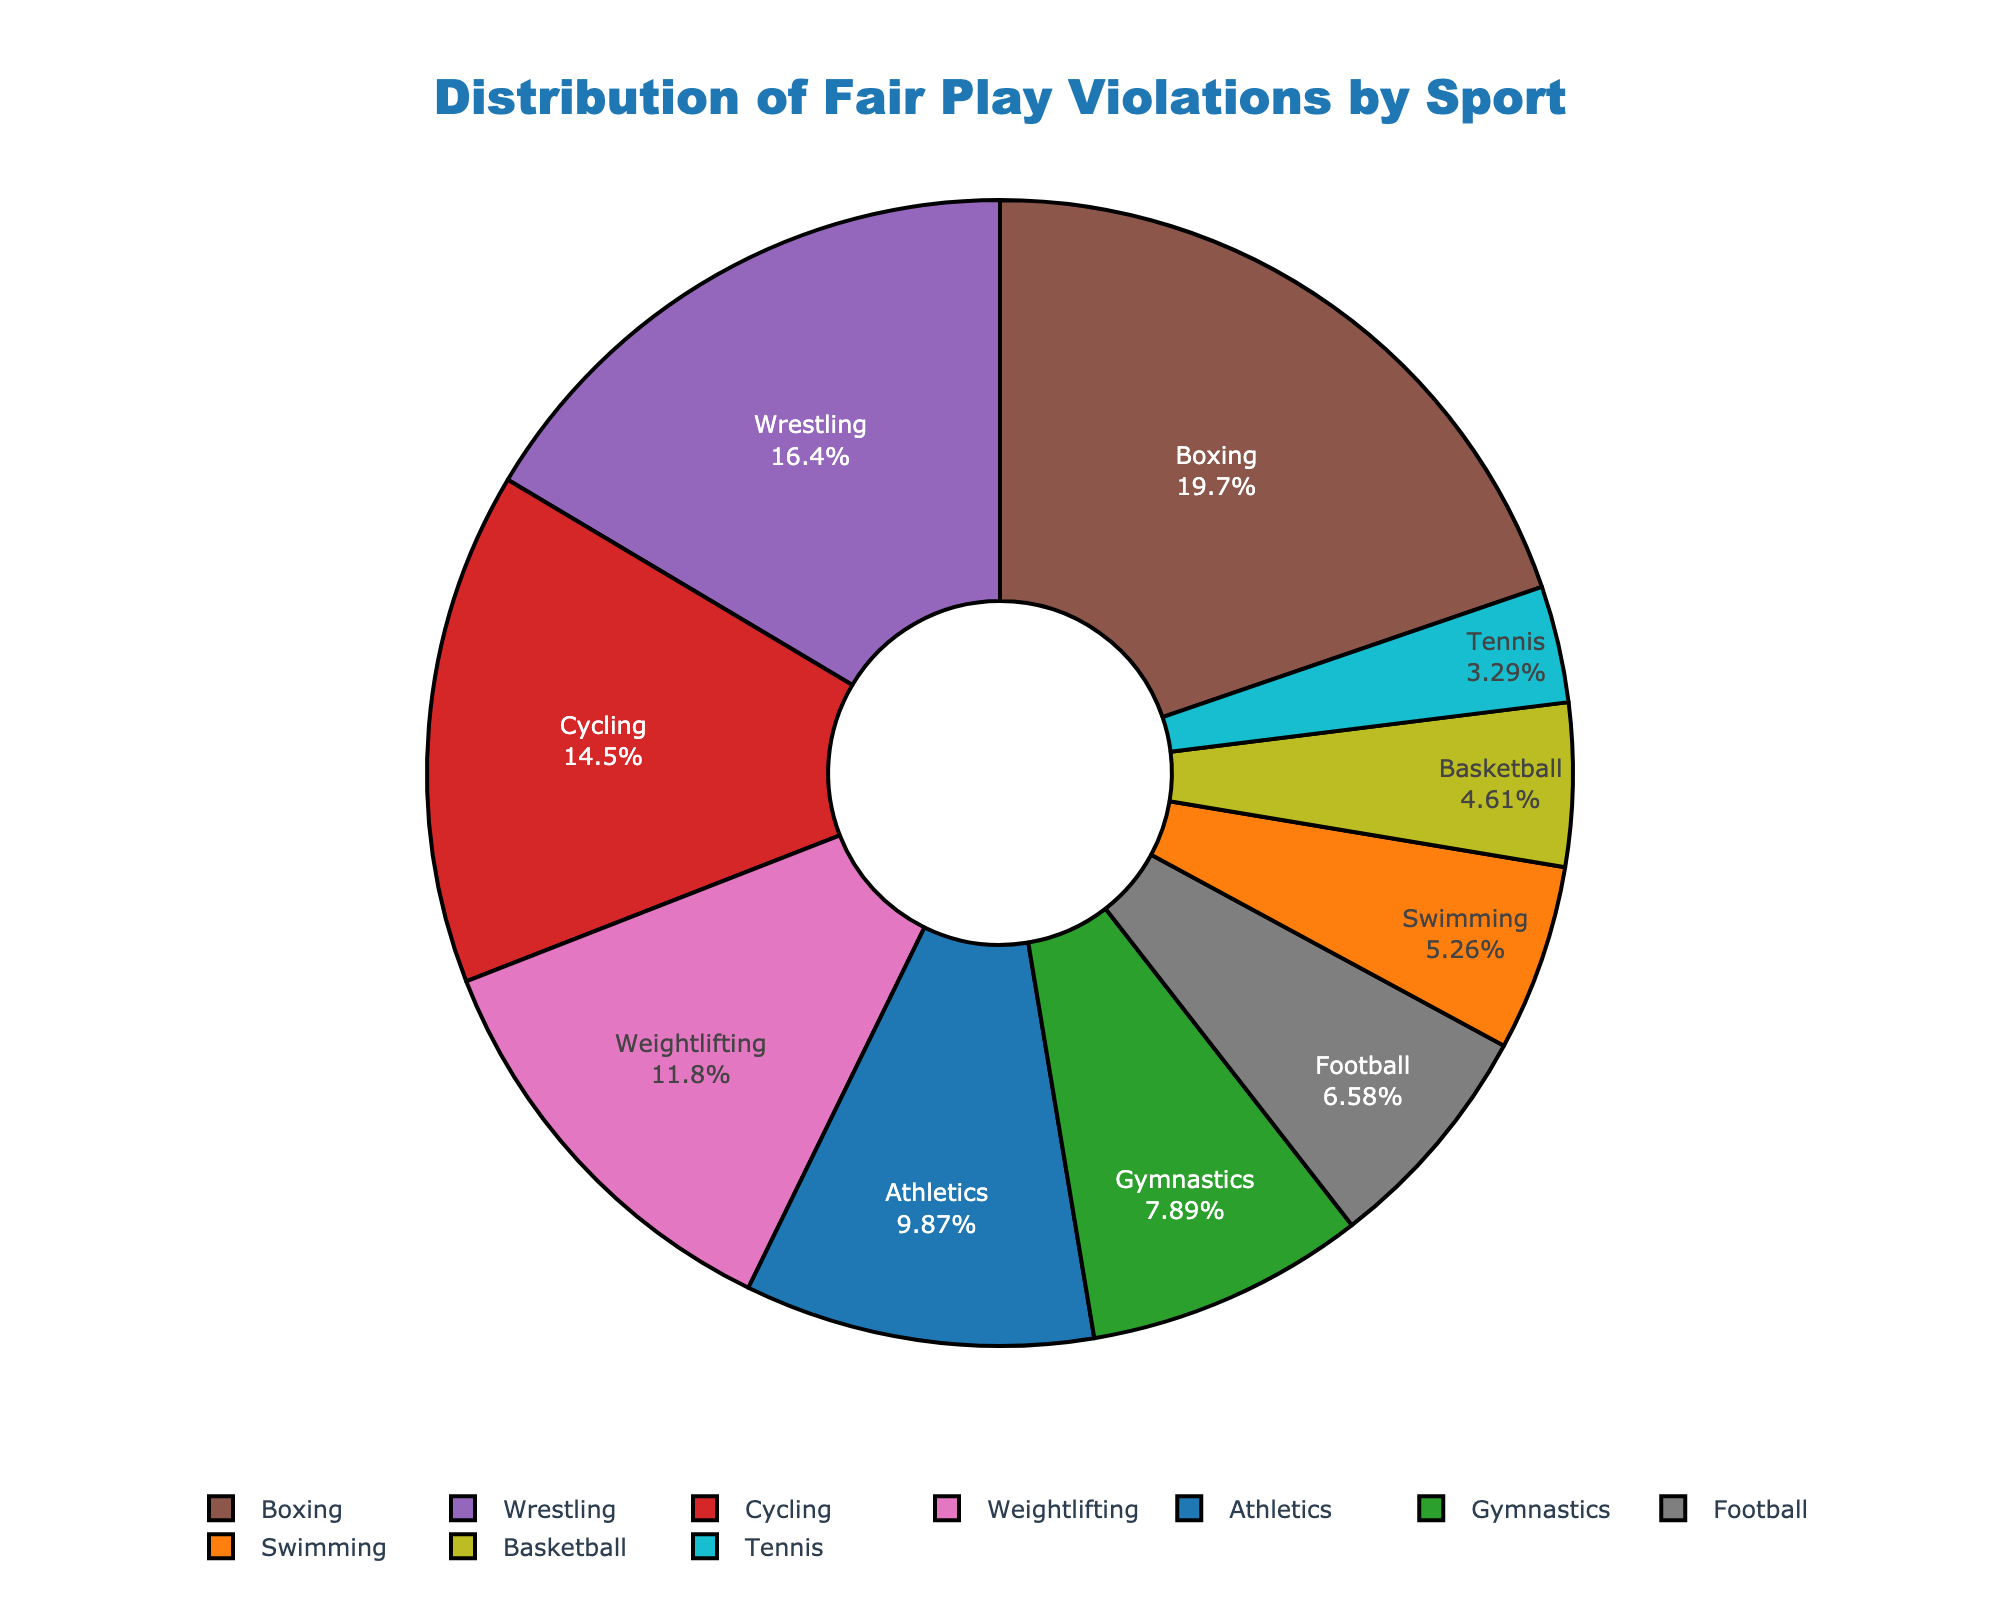What is the title of the plot? The title is typically found at the top of the figure. In this plot, it clearly states that the data represents customer satisfaction ratings by product feature.
Answer: Customer Satisfaction Ratings by Product Feature Which product line has the highest satisfaction rating for any feature? To answer this, look for the highest y-value across all subplots. In the "Smartphones" subplot, Camera Quality has a rating of 4.7, the highest in the figure.
Answer: Smartphones Which product feature has the highest satisfaction rating in the Laptops product line? In the Laptops subplot, compare y-values for different features. Display Quality has the highest rating with a 4.4.
Answer: Display Quality What is the average satisfaction rating for Battery Life across all product lines? Collect satisfaction ratings for Battery Life from Smartphones (4.2), Laptops (3.9), Smart Watches (3.8), and Tablets (4.0). Calculate the average (4.2 + 3.9 + 3.8 + 4.0) / 4 = 4.0.
Answer: 4.0 Which product line has the feature with the smallest customer count, and what is that count? Look for the smallest circle size, indicating customer count. Stylus Responsiveness in Tablets has the smallest customer count of 75.
Answer: Tablets, 75 What is the difference in satisfaction ratings between the highest and lowest-rated features within the Smart Watches product line? The highest rated feature in Smart Watches is Water Resistance (4.6), and the lowest is Battery Life (3.8). The difference is 4.6 - 3.8 = 0.8.
Answer: 0.8 In the Smartphones product line, which feature has the closest satisfaction rating to Processing Speed? Compare y-values of the features in Smartphones. Processing Speed rating is 4.5. Display Resolution, with a rating of 4.6, is the closest.
Answer: Display Resolution Which feature in Smart Watches has less satisfaction rating than any feature in Tablets? Compare the lowest rating in Smart Watches (Battery Life, 3.8) with the features in Tablets (all > 4.0). Battery Life in Smart Watches is less than all features in Tablets.
Answer: Battery Life 